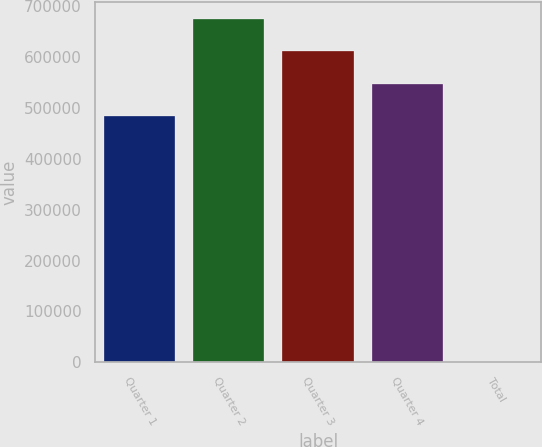<chart> <loc_0><loc_0><loc_500><loc_500><bar_chart><fcel>Quarter 1<fcel>Quarter 2<fcel>Quarter 3<fcel>Quarter 4<fcel>Total<nl><fcel>484223<fcel>673500<fcel>610408<fcel>547315<fcel>10.15<nl></chart> 